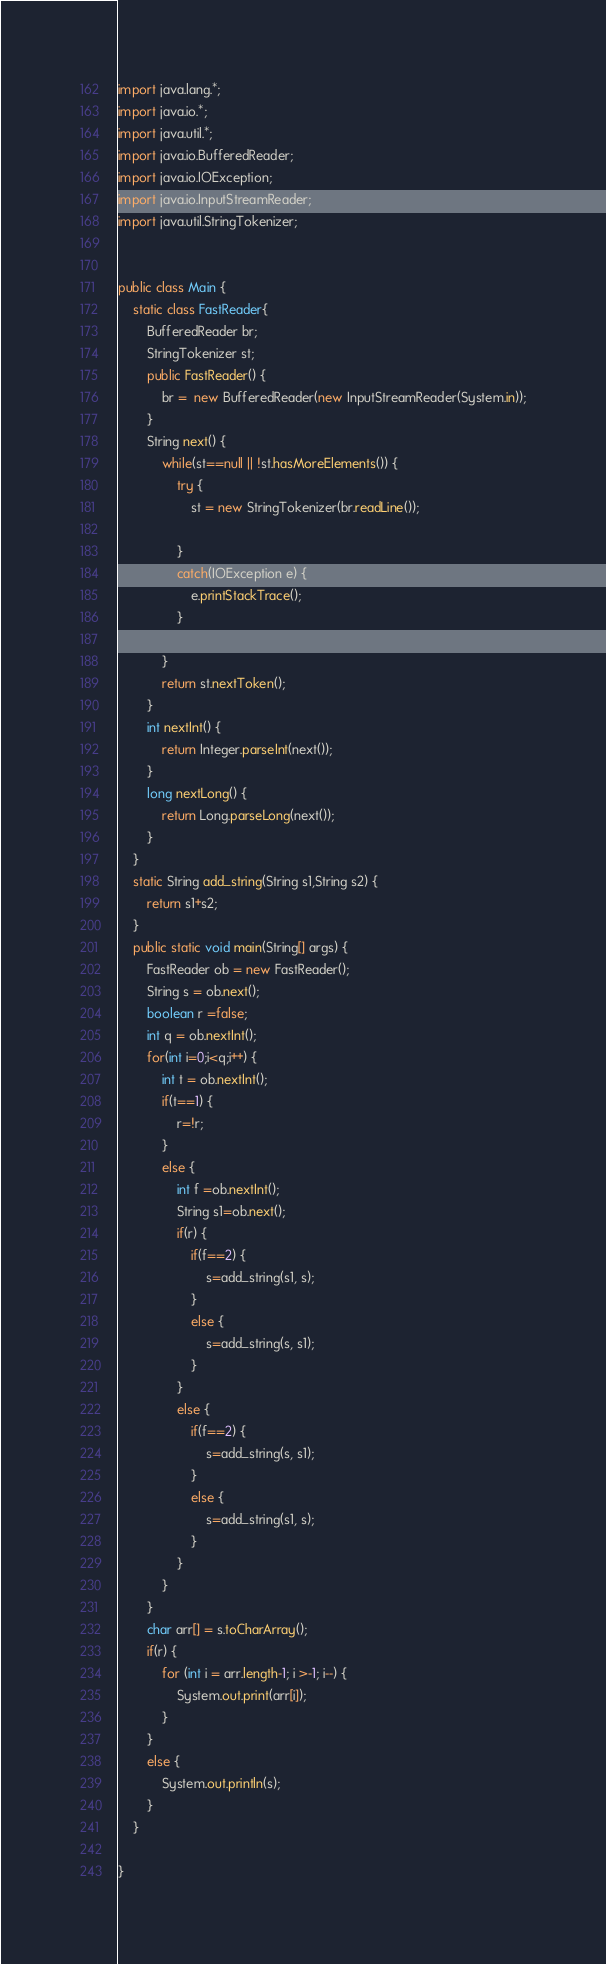<code> <loc_0><loc_0><loc_500><loc_500><_Java_>import java.lang.*; 
import java.io.*; 
import java.util.*; 
import java.io.BufferedReader;
import java.io.IOException;
import java.io.InputStreamReader;
import java.util.StringTokenizer;


public class Main {
	static class FastReader{
		BufferedReader br;
		StringTokenizer st;
		public FastReader() {
			br =  new BufferedReader(new InputStreamReader(System.in));
		}
		String next() {
			while(st==null || !st.hasMoreElements()) {
				try {
					st = new StringTokenizer(br.readLine());
					
				}
				catch(IOException e) {
					e.printStackTrace();
				}
				
			}
			return st.nextToken();
		}
		int nextInt() {
			return Integer.parseInt(next());
		}
		long nextLong() {
			return Long.parseLong(next());
		}
	}
	static String add_string(String s1,String s2) {
		return s1+s2;
	}
	public static void main(String[] args) {
		FastReader ob = new FastReader();
		String s = ob.next();
		boolean r =false;
		int q = ob.nextInt();
		for(int i=0;i<q;i++) {
			int t = ob.nextInt();
			if(t==1) {
				r=!r;
			}
			else {
				int f =ob.nextInt();
				String s1=ob.next();
				if(r) {
					if(f==2) {
						s=add_string(s1, s);
					}
					else {
						s=add_string(s, s1);
					}
				}
				else {
					if(f==2) {
						s=add_string(s, s1);
					}
					else {
						s=add_string(s1, s);
					}
				}
			}
		}
		char arr[] = s.toCharArray();
		if(r) {
			for (int i = arr.length-1; i >-1; i--) {
				System.out.print(arr[i]);
			}
		}
		else {
			System.out.println(s);
		}
	}

}
</code> 